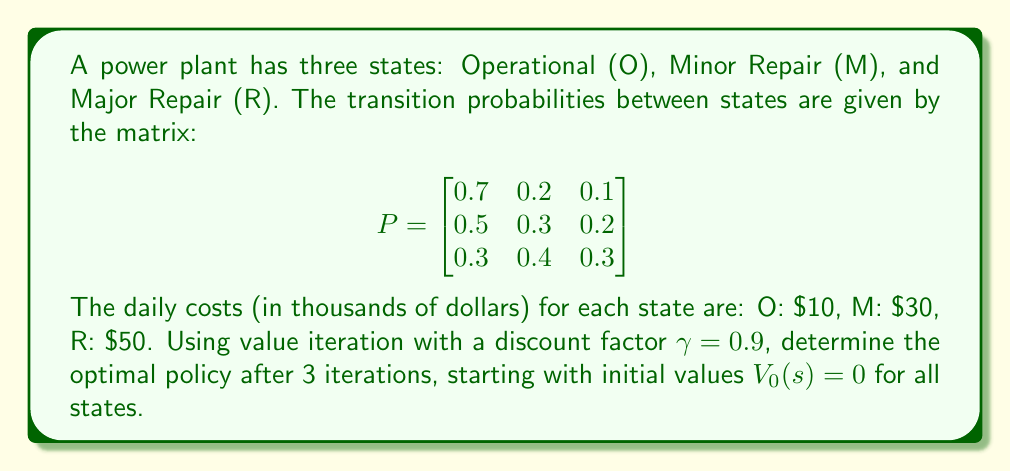Provide a solution to this math problem. Let's solve this step-by-step using value iteration:

1) First, we define the value function:
   $$V_{n+1}(s) = \min_a \left\{c(s) + \gamma \sum_{s'} P(s'|s,a) V_n(s')\right\}$$
   where $c(s)$ is the cost of being in state $s$.

2) Initial values: $V_0(O) = V_0(M) = V_0(R) = 0$

3) First iteration (n = 1):
   $$V_1(O) = 10 + 0.9(0.7 \cdot 0 + 0.2 \cdot 0 + 0.1 \cdot 0) = 10$$
   $$V_1(M) = 30 + 0.9(0.5 \cdot 0 + 0.3 \cdot 0 + 0.2 \cdot 0) = 30$$
   $$V_1(R) = 50 + 0.9(0.3 \cdot 0 + 0.4 \cdot 0 + 0.3 \cdot 0) = 50$$

4) Second iteration (n = 2):
   $$V_2(O) = 10 + 0.9(0.7 \cdot 10 + 0.2 \cdot 30 + 0.1 \cdot 50) = 24.3$$
   $$V_2(M) = 30 + 0.9(0.5 \cdot 10 + 0.3 \cdot 30 + 0.2 \cdot 50) = 43.5$$
   $$V_2(R) = 50 + 0.9(0.3 \cdot 10 + 0.4 \cdot 30 + 0.3 \cdot 50) = 64.5$$

5) Third iteration (n = 3):
   $$V_3(O) = 10 + 0.9(0.7 \cdot 24.3 + 0.2 \cdot 43.5 + 0.1 \cdot 64.5) = 35.73$$
   $$V_3(M) = 30 + 0.9(0.5 \cdot 24.3 + 0.3 \cdot 43.5 + 0.2 \cdot 64.5) = 53.145$$
   $$V_3(R) = 50 + 0.9(0.3 \cdot 24.3 + 0.4 \cdot 43.5 + 0.3 \cdot 64.5) = 72.945$$

6) The optimal policy is to choose the action that leads to the state with the lowest value. After 3 iterations, the optimal policy is to always aim for the Operational state, as it has the lowest value in all cases.
Answer: Always aim for the Operational state. 